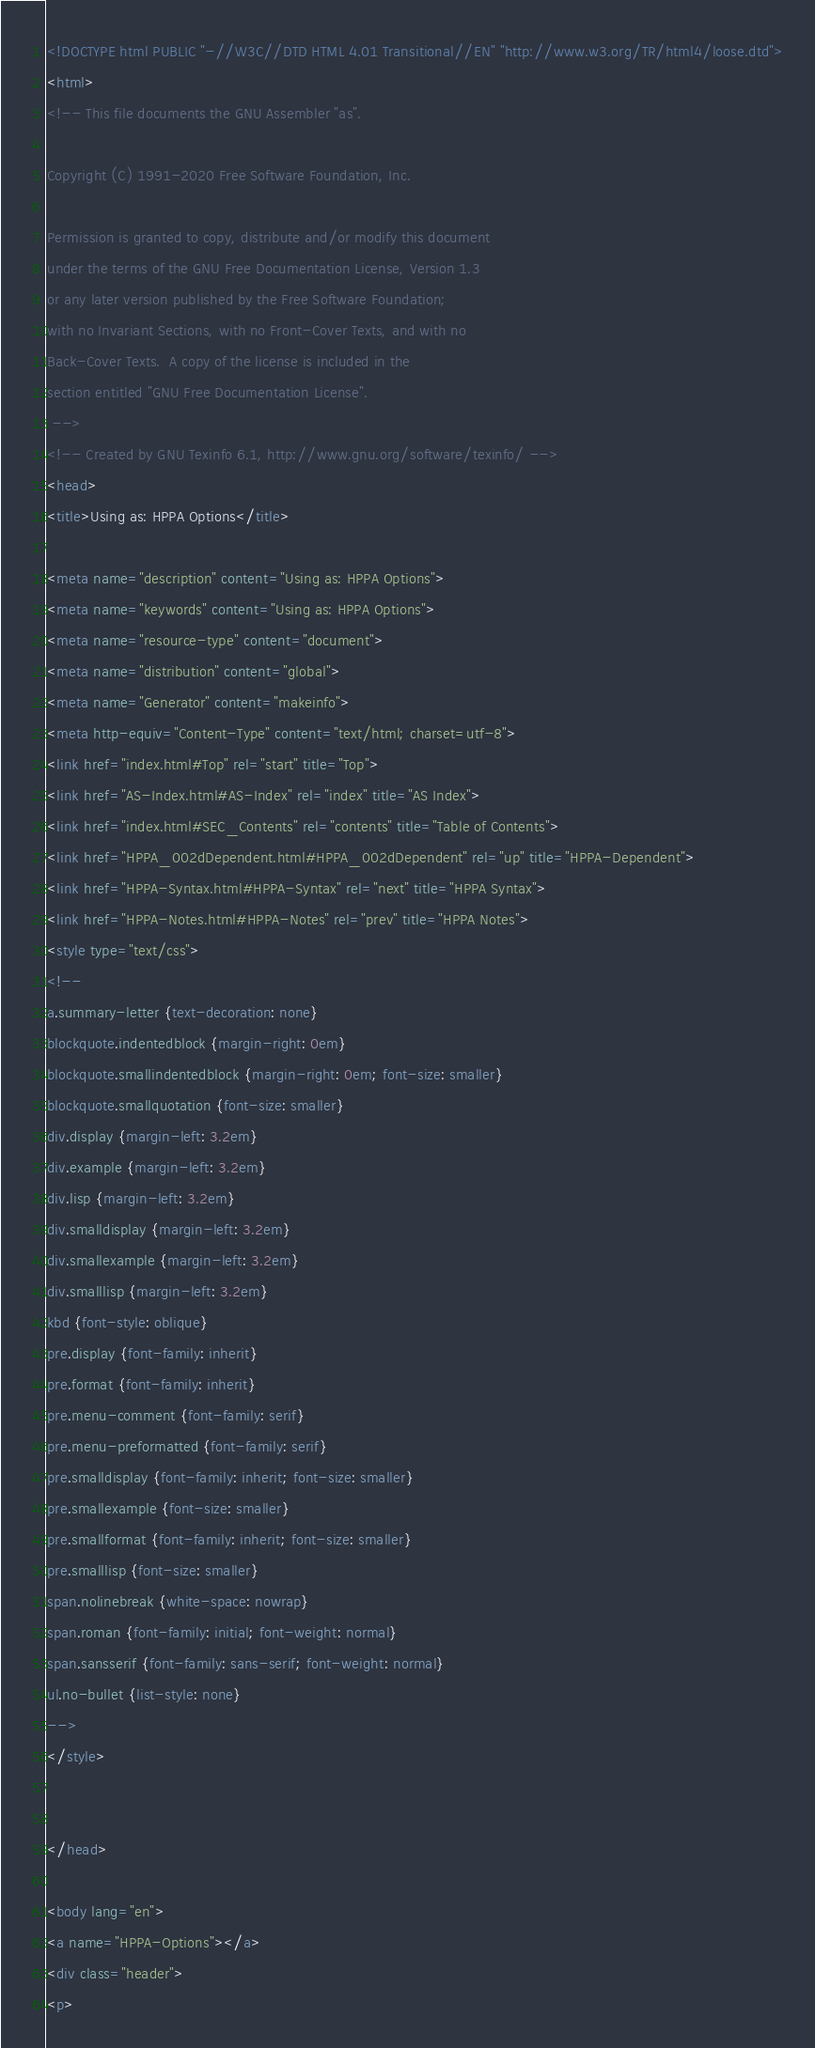<code> <loc_0><loc_0><loc_500><loc_500><_HTML_><!DOCTYPE html PUBLIC "-//W3C//DTD HTML 4.01 Transitional//EN" "http://www.w3.org/TR/html4/loose.dtd">
<html>
<!-- This file documents the GNU Assembler "as".

Copyright (C) 1991-2020 Free Software Foundation, Inc.

Permission is granted to copy, distribute and/or modify this document
under the terms of the GNU Free Documentation License, Version 1.3
or any later version published by the Free Software Foundation;
with no Invariant Sections, with no Front-Cover Texts, and with no
Back-Cover Texts.  A copy of the license is included in the
section entitled "GNU Free Documentation License".
 -->
<!-- Created by GNU Texinfo 6.1, http://www.gnu.org/software/texinfo/ -->
<head>
<title>Using as: HPPA Options</title>

<meta name="description" content="Using as: HPPA Options">
<meta name="keywords" content="Using as: HPPA Options">
<meta name="resource-type" content="document">
<meta name="distribution" content="global">
<meta name="Generator" content="makeinfo">
<meta http-equiv="Content-Type" content="text/html; charset=utf-8">
<link href="index.html#Top" rel="start" title="Top">
<link href="AS-Index.html#AS-Index" rel="index" title="AS Index">
<link href="index.html#SEC_Contents" rel="contents" title="Table of Contents">
<link href="HPPA_002dDependent.html#HPPA_002dDependent" rel="up" title="HPPA-Dependent">
<link href="HPPA-Syntax.html#HPPA-Syntax" rel="next" title="HPPA Syntax">
<link href="HPPA-Notes.html#HPPA-Notes" rel="prev" title="HPPA Notes">
<style type="text/css">
<!--
a.summary-letter {text-decoration: none}
blockquote.indentedblock {margin-right: 0em}
blockquote.smallindentedblock {margin-right: 0em; font-size: smaller}
blockquote.smallquotation {font-size: smaller}
div.display {margin-left: 3.2em}
div.example {margin-left: 3.2em}
div.lisp {margin-left: 3.2em}
div.smalldisplay {margin-left: 3.2em}
div.smallexample {margin-left: 3.2em}
div.smalllisp {margin-left: 3.2em}
kbd {font-style: oblique}
pre.display {font-family: inherit}
pre.format {font-family: inherit}
pre.menu-comment {font-family: serif}
pre.menu-preformatted {font-family: serif}
pre.smalldisplay {font-family: inherit; font-size: smaller}
pre.smallexample {font-size: smaller}
pre.smallformat {font-family: inherit; font-size: smaller}
pre.smalllisp {font-size: smaller}
span.nolinebreak {white-space: nowrap}
span.roman {font-family: initial; font-weight: normal}
span.sansserif {font-family: sans-serif; font-weight: normal}
ul.no-bullet {list-style: none}
-->
</style>


</head>

<body lang="en">
<a name="HPPA-Options"></a>
<div class="header">
<p></code> 